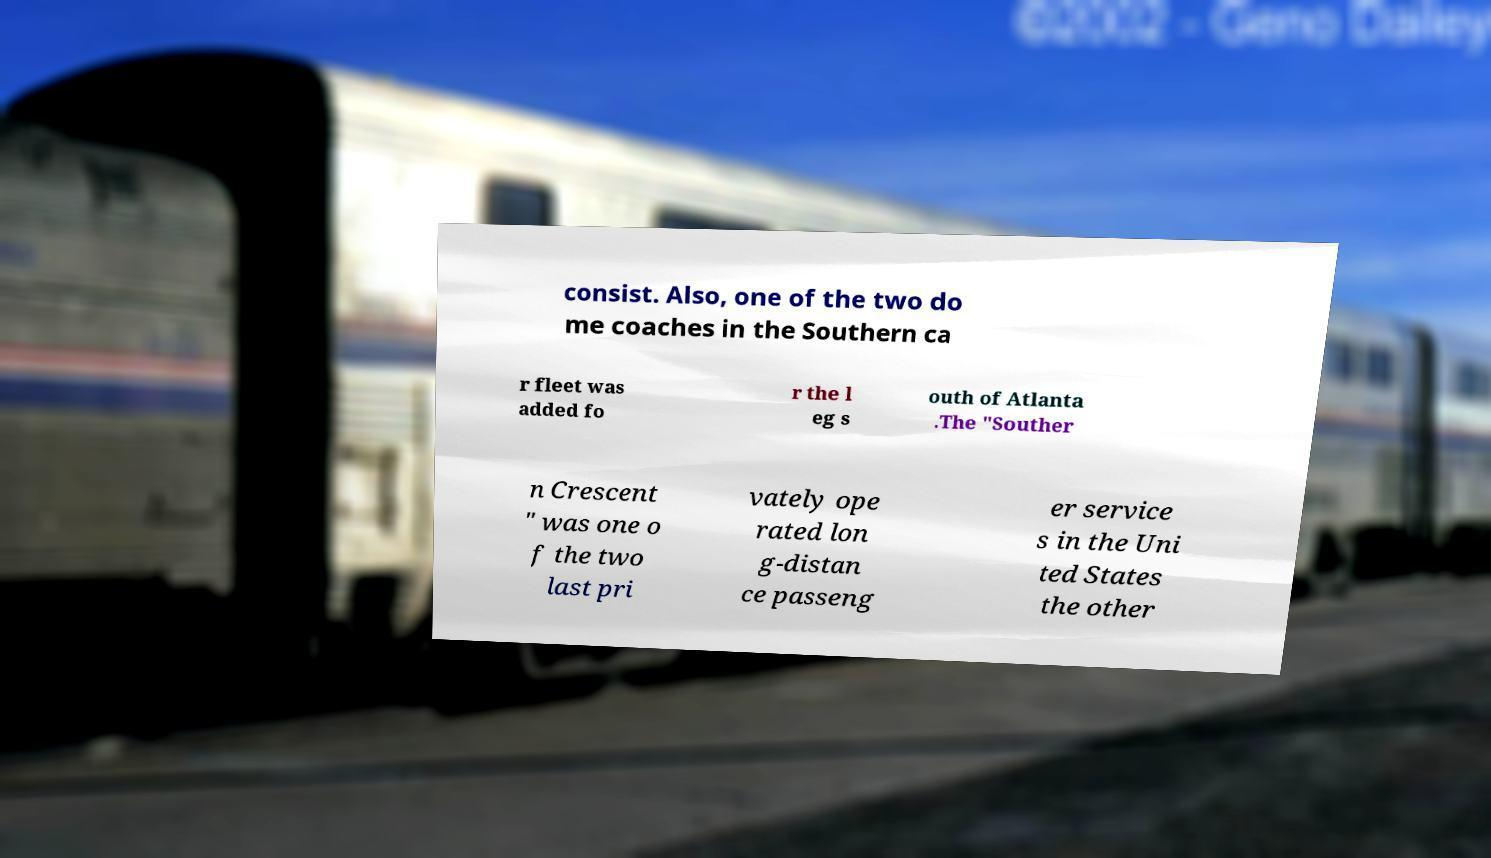Please read and relay the text visible in this image. What does it say? consist. Also, one of the two do me coaches in the Southern ca r fleet was added fo r the l eg s outh of Atlanta .The "Souther n Crescent " was one o f the two last pri vately ope rated lon g-distan ce passeng er service s in the Uni ted States the other 